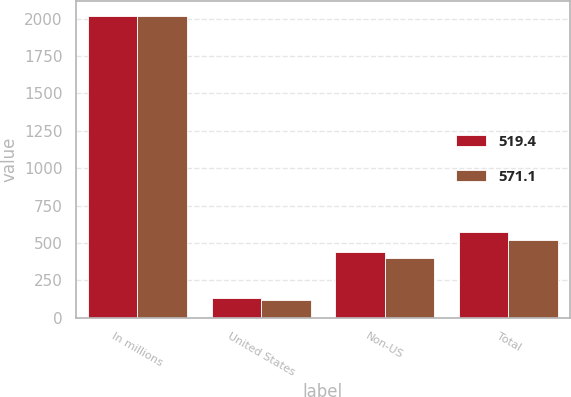Convert chart to OTSL. <chart><loc_0><loc_0><loc_500><loc_500><stacked_bar_chart><ecel><fcel>In millions<fcel>United States<fcel>Non-US<fcel>Total<nl><fcel>519.4<fcel>2017<fcel>131<fcel>440.1<fcel>571.1<nl><fcel>571.1<fcel>2016<fcel>117.1<fcel>402.3<fcel>519.4<nl></chart> 